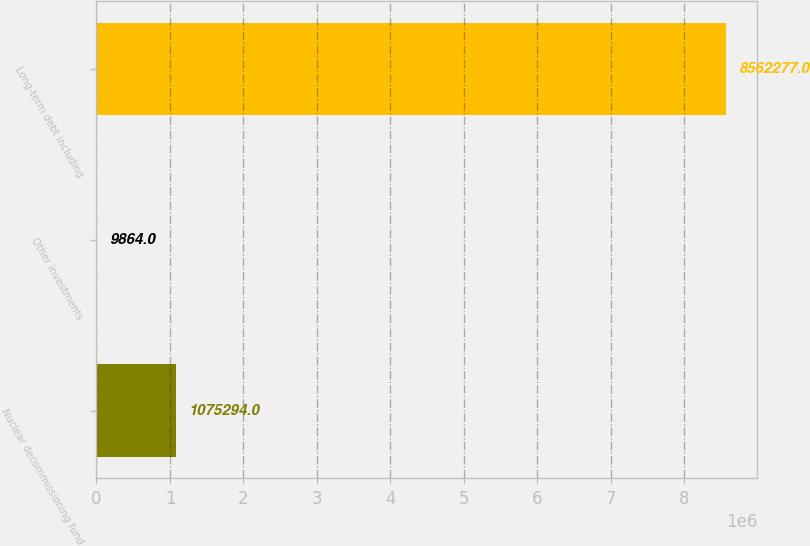Convert chart to OTSL. <chart><loc_0><loc_0><loc_500><loc_500><bar_chart><fcel>Nuclear decommissioning fund<fcel>Other investments<fcel>Long-term debt including<nl><fcel>1.07529e+06<fcel>9864<fcel>8.56228e+06<nl></chart> 